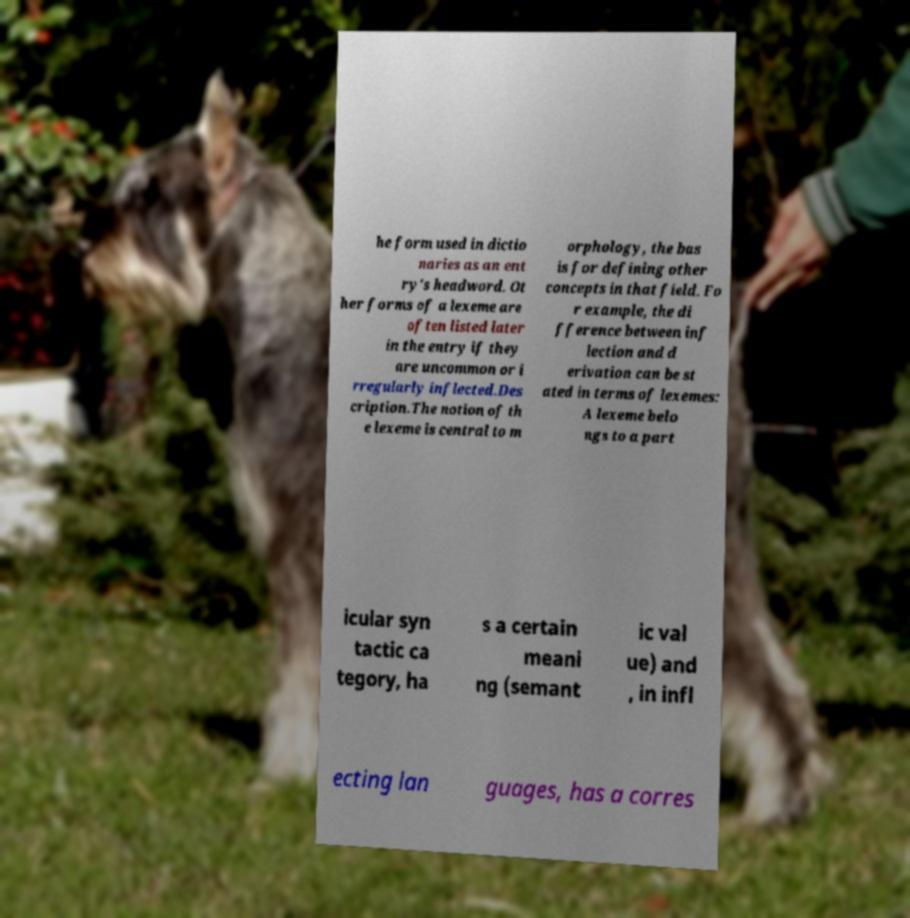Please identify and transcribe the text found in this image. he form used in dictio naries as an ent ry's headword. Ot her forms of a lexeme are often listed later in the entry if they are uncommon or i rregularly inflected.Des cription.The notion of th e lexeme is central to m orphology, the bas is for defining other concepts in that field. Fo r example, the di fference between inf lection and d erivation can be st ated in terms of lexemes: A lexeme belo ngs to a part icular syn tactic ca tegory, ha s a certain meani ng (semant ic val ue) and , in infl ecting lan guages, has a corres 